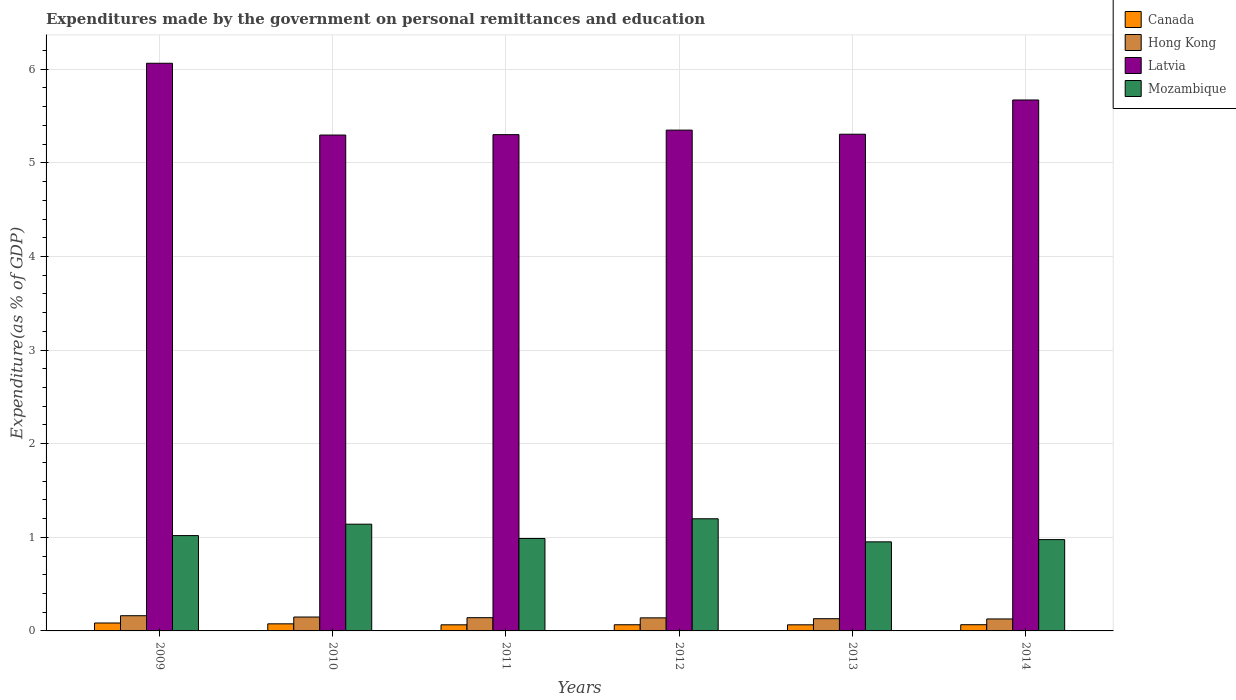Are the number of bars per tick equal to the number of legend labels?
Your answer should be compact. Yes. Are the number of bars on each tick of the X-axis equal?
Your response must be concise. Yes. How many bars are there on the 5th tick from the left?
Give a very brief answer. 4. How many bars are there on the 3rd tick from the right?
Your answer should be compact. 4. What is the label of the 2nd group of bars from the left?
Your answer should be compact. 2010. What is the expenditures made by the government on personal remittances and education in Mozambique in 2011?
Offer a terse response. 0.99. Across all years, what is the maximum expenditures made by the government on personal remittances and education in Latvia?
Your answer should be very brief. 6.06. Across all years, what is the minimum expenditures made by the government on personal remittances and education in Latvia?
Offer a very short reply. 5.3. In which year was the expenditures made by the government on personal remittances and education in Mozambique minimum?
Your answer should be very brief. 2013. What is the total expenditures made by the government on personal remittances and education in Canada in the graph?
Provide a short and direct response. 0.42. What is the difference between the expenditures made by the government on personal remittances and education in Canada in 2013 and that in 2014?
Your response must be concise. -0. What is the difference between the expenditures made by the government on personal remittances and education in Hong Kong in 2011 and the expenditures made by the government on personal remittances and education in Latvia in 2014?
Your answer should be very brief. -5.53. What is the average expenditures made by the government on personal remittances and education in Latvia per year?
Your answer should be very brief. 5.5. In the year 2011, what is the difference between the expenditures made by the government on personal remittances and education in Hong Kong and expenditures made by the government on personal remittances and education in Latvia?
Provide a succinct answer. -5.16. What is the ratio of the expenditures made by the government on personal remittances and education in Hong Kong in 2010 to that in 2012?
Ensure brevity in your answer.  1.06. Is the expenditures made by the government on personal remittances and education in Latvia in 2011 less than that in 2013?
Provide a short and direct response. Yes. Is the difference between the expenditures made by the government on personal remittances and education in Hong Kong in 2009 and 2014 greater than the difference between the expenditures made by the government on personal remittances and education in Latvia in 2009 and 2014?
Keep it short and to the point. No. What is the difference between the highest and the second highest expenditures made by the government on personal remittances and education in Mozambique?
Provide a succinct answer. 0.06. What is the difference between the highest and the lowest expenditures made by the government on personal remittances and education in Mozambique?
Give a very brief answer. 0.25. Is the sum of the expenditures made by the government on personal remittances and education in Hong Kong in 2009 and 2014 greater than the maximum expenditures made by the government on personal remittances and education in Mozambique across all years?
Your answer should be very brief. No. What does the 4th bar from the left in 2009 represents?
Your answer should be very brief. Mozambique. What does the 4th bar from the right in 2010 represents?
Your answer should be very brief. Canada. Is it the case that in every year, the sum of the expenditures made by the government on personal remittances and education in Hong Kong and expenditures made by the government on personal remittances and education in Mozambique is greater than the expenditures made by the government on personal remittances and education in Latvia?
Give a very brief answer. No. How many bars are there?
Ensure brevity in your answer.  24. How many years are there in the graph?
Provide a short and direct response. 6. Does the graph contain grids?
Give a very brief answer. Yes. Where does the legend appear in the graph?
Your answer should be very brief. Top right. What is the title of the graph?
Offer a terse response. Expenditures made by the government on personal remittances and education. What is the label or title of the Y-axis?
Your answer should be very brief. Expenditure(as % of GDP). What is the Expenditure(as % of GDP) in Canada in 2009?
Give a very brief answer. 0.08. What is the Expenditure(as % of GDP) of Hong Kong in 2009?
Offer a terse response. 0.16. What is the Expenditure(as % of GDP) of Latvia in 2009?
Offer a terse response. 6.06. What is the Expenditure(as % of GDP) in Mozambique in 2009?
Offer a terse response. 1.02. What is the Expenditure(as % of GDP) in Canada in 2010?
Your answer should be compact. 0.08. What is the Expenditure(as % of GDP) of Hong Kong in 2010?
Provide a short and direct response. 0.15. What is the Expenditure(as % of GDP) in Latvia in 2010?
Your response must be concise. 5.3. What is the Expenditure(as % of GDP) in Mozambique in 2010?
Offer a terse response. 1.14. What is the Expenditure(as % of GDP) in Canada in 2011?
Ensure brevity in your answer.  0.07. What is the Expenditure(as % of GDP) in Hong Kong in 2011?
Provide a short and direct response. 0.14. What is the Expenditure(as % of GDP) of Latvia in 2011?
Give a very brief answer. 5.3. What is the Expenditure(as % of GDP) in Mozambique in 2011?
Ensure brevity in your answer.  0.99. What is the Expenditure(as % of GDP) of Canada in 2012?
Your response must be concise. 0.07. What is the Expenditure(as % of GDP) in Hong Kong in 2012?
Offer a terse response. 0.14. What is the Expenditure(as % of GDP) of Latvia in 2012?
Give a very brief answer. 5.35. What is the Expenditure(as % of GDP) in Mozambique in 2012?
Provide a succinct answer. 1.2. What is the Expenditure(as % of GDP) in Canada in 2013?
Make the answer very short. 0.07. What is the Expenditure(as % of GDP) in Hong Kong in 2013?
Ensure brevity in your answer.  0.13. What is the Expenditure(as % of GDP) in Latvia in 2013?
Your answer should be very brief. 5.31. What is the Expenditure(as % of GDP) in Mozambique in 2013?
Your answer should be compact. 0.95. What is the Expenditure(as % of GDP) of Canada in 2014?
Ensure brevity in your answer.  0.07. What is the Expenditure(as % of GDP) in Hong Kong in 2014?
Keep it short and to the point. 0.13. What is the Expenditure(as % of GDP) of Latvia in 2014?
Make the answer very short. 5.67. What is the Expenditure(as % of GDP) of Mozambique in 2014?
Offer a very short reply. 0.98. Across all years, what is the maximum Expenditure(as % of GDP) in Canada?
Make the answer very short. 0.08. Across all years, what is the maximum Expenditure(as % of GDP) of Hong Kong?
Offer a very short reply. 0.16. Across all years, what is the maximum Expenditure(as % of GDP) in Latvia?
Keep it short and to the point. 6.06. Across all years, what is the maximum Expenditure(as % of GDP) in Mozambique?
Provide a succinct answer. 1.2. Across all years, what is the minimum Expenditure(as % of GDP) in Canada?
Your answer should be very brief. 0.07. Across all years, what is the minimum Expenditure(as % of GDP) of Hong Kong?
Provide a succinct answer. 0.13. Across all years, what is the minimum Expenditure(as % of GDP) of Latvia?
Your answer should be very brief. 5.3. Across all years, what is the minimum Expenditure(as % of GDP) of Mozambique?
Provide a succinct answer. 0.95. What is the total Expenditure(as % of GDP) of Canada in the graph?
Provide a succinct answer. 0.42. What is the total Expenditure(as % of GDP) of Hong Kong in the graph?
Provide a short and direct response. 0.85. What is the total Expenditure(as % of GDP) of Latvia in the graph?
Provide a short and direct response. 32.99. What is the total Expenditure(as % of GDP) in Mozambique in the graph?
Your answer should be compact. 6.27. What is the difference between the Expenditure(as % of GDP) in Canada in 2009 and that in 2010?
Make the answer very short. 0.01. What is the difference between the Expenditure(as % of GDP) of Hong Kong in 2009 and that in 2010?
Your response must be concise. 0.01. What is the difference between the Expenditure(as % of GDP) in Latvia in 2009 and that in 2010?
Offer a very short reply. 0.77. What is the difference between the Expenditure(as % of GDP) in Mozambique in 2009 and that in 2010?
Make the answer very short. -0.12. What is the difference between the Expenditure(as % of GDP) in Canada in 2009 and that in 2011?
Keep it short and to the point. 0.02. What is the difference between the Expenditure(as % of GDP) in Hong Kong in 2009 and that in 2011?
Your answer should be very brief. 0.02. What is the difference between the Expenditure(as % of GDP) of Latvia in 2009 and that in 2011?
Ensure brevity in your answer.  0.76. What is the difference between the Expenditure(as % of GDP) of Mozambique in 2009 and that in 2011?
Offer a terse response. 0.03. What is the difference between the Expenditure(as % of GDP) of Canada in 2009 and that in 2012?
Your answer should be compact. 0.02. What is the difference between the Expenditure(as % of GDP) in Hong Kong in 2009 and that in 2012?
Provide a succinct answer. 0.02. What is the difference between the Expenditure(as % of GDP) in Latvia in 2009 and that in 2012?
Offer a very short reply. 0.71. What is the difference between the Expenditure(as % of GDP) in Mozambique in 2009 and that in 2012?
Ensure brevity in your answer.  -0.18. What is the difference between the Expenditure(as % of GDP) in Canada in 2009 and that in 2013?
Your answer should be very brief. 0.02. What is the difference between the Expenditure(as % of GDP) of Hong Kong in 2009 and that in 2013?
Give a very brief answer. 0.03. What is the difference between the Expenditure(as % of GDP) of Latvia in 2009 and that in 2013?
Your answer should be very brief. 0.76. What is the difference between the Expenditure(as % of GDP) in Mozambique in 2009 and that in 2013?
Provide a short and direct response. 0.07. What is the difference between the Expenditure(as % of GDP) in Canada in 2009 and that in 2014?
Your answer should be compact. 0.02. What is the difference between the Expenditure(as % of GDP) in Hong Kong in 2009 and that in 2014?
Offer a terse response. 0.03. What is the difference between the Expenditure(as % of GDP) in Latvia in 2009 and that in 2014?
Provide a short and direct response. 0.39. What is the difference between the Expenditure(as % of GDP) of Mozambique in 2009 and that in 2014?
Keep it short and to the point. 0.04. What is the difference between the Expenditure(as % of GDP) in Canada in 2010 and that in 2011?
Provide a short and direct response. 0.01. What is the difference between the Expenditure(as % of GDP) in Hong Kong in 2010 and that in 2011?
Offer a very short reply. 0.01. What is the difference between the Expenditure(as % of GDP) of Latvia in 2010 and that in 2011?
Make the answer very short. -0. What is the difference between the Expenditure(as % of GDP) in Mozambique in 2010 and that in 2011?
Ensure brevity in your answer.  0.15. What is the difference between the Expenditure(as % of GDP) of Canada in 2010 and that in 2012?
Your response must be concise. 0.01. What is the difference between the Expenditure(as % of GDP) of Hong Kong in 2010 and that in 2012?
Make the answer very short. 0.01. What is the difference between the Expenditure(as % of GDP) of Latvia in 2010 and that in 2012?
Offer a very short reply. -0.05. What is the difference between the Expenditure(as % of GDP) of Mozambique in 2010 and that in 2012?
Provide a short and direct response. -0.06. What is the difference between the Expenditure(as % of GDP) of Canada in 2010 and that in 2013?
Give a very brief answer. 0.01. What is the difference between the Expenditure(as % of GDP) of Hong Kong in 2010 and that in 2013?
Offer a terse response. 0.02. What is the difference between the Expenditure(as % of GDP) in Latvia in 2010 and that in 2013?
Provide a short and direct response. -0.01. What is the difference between the Expenditure(as % of GDP) in Mozambique in 2010 and that in 2013?
Ensure brevity in your answer.  0.19. What is the difference between the Expenditure(as % of GDP) of Canada in 2010 and that in 2014?
Give a very brief answer. 0.01. What is the difference between the Expenditure(as % of GDP) in Hong Kong in 2010 and that in 2014?
Give a very brief answer. 0.02. What is the difference between the Expenditure(as % of GDP) of Latvia in 2010 and that in 2014?
Ensure brevity in your answer.  -0.37. What is the difference between the Expenditure(as % of GDP) of Mozambique in 2010 and that in 2014?
Ensure brevity in your answer.  0.16. What is the difference between the Expenditure(as % of GDP) in Canada in 2011 and that in 2012?
Make the answer very short. -0. What is the difference between the Expenditure(as % of GDP) of Hong Kong in 2011 and that in 2012?
Provide a succinct answer. 0. What is the difference between the Expenditure(as % of GDP) of Latvia in 2011 and that in 2012?
Your response must be concise. -0.05. What is the difference between the Expenditure(as % of GDP) of Mozambique in 2011 and that in 2012?
Offer a terse response. -0.21. What is the difference between the Expenditure(as % of GDP) in Canada in 2011 and that in 2013?
Ensure brevity in your answer.  -0. What is the difference between the Expenditure(as % of GDP) of Hong Kong in 2011 and that in 2013?
Keep it short and to the point. 0.01. What is the difference between the Expenditure(as % of GDP) in Latvia in 2011 and that in 2013?
Your answer should be very brief. -0. What is the difference between the Expenditure(as % of GDP) of Mozambique in 2011 and that in 2013?
Make the answer very short. 0.04. What is the difference between the Expenditure(as % of GDP) in Canada in 2011 and that in 2014?
Give a very brief answer. -0. What is the difference between the Expenditure(as % of GDP) in Hong Kong in 2011 and that in 2014?
Give a very brief answer. 0.01. What is the difference between the Expenditure(as % of GDP) of Latvia in 2011 and that in 2014?
Your answer should be compact. -0.37. What is the difference between the Expenditure(as % of GDP) in Mozambique in 2011 and that in 2014?
Your response must be concise. 0.01. What is the difference between the Expenditure(as % of GDP) of Canada in 2012 and that in 2013?
Give a very brief answer. 0. What is the difference between the Expenditure(as % of GDP) of Hong Kong in 2012 and that in 2013?
Provide a short and direct response. 0.01. What is the difference between the Expenditure(as % of GDP) in Latvia in 2012 and that in 2013?
Your answer should be very brief. 0.04. What is the difference between the Expenditure(as % of GDP) in Mozambique in 2012 and that in 2013?
Your answer should be compact. 0.25. What is the difference between the Expenditure(as % of GDP) in Canada in 2012 and that in 2014?
Provide a short and direct response. -0. What is the difference between the Expenditure(as % of GDP) of Hong Kong in 2012 and that in 2014?
Give a very brief answer. 0.01. What is the difference between the Expenditure(as % of GDP) of Latvia in 2012 and that in 2014?
Keep it short and to the point. -0.32. What is the difference between the Expenditure(as % of GDP) of Mozambique in 2012 and that in 2014?
Give a very brief answer. 0.22. What is the difference between the Expenditure(as % of GDP) of Canada in 2013 and that in 2014?
Make the answer very short. -0. What is the difference between the Expenditure(as % of GDP) of Hong Kong in 2013 and that in 2014?
Give a very brief answer. 0. What is the difference between the Expenditure(as % of GDP) of Latvia in 2013 and that in 2014?
Ensure brevity in your answer.  -0.37. What is the difference between the Expenditure(as % of GDP) of Mozambique in 2013 and that in 2014?
Ensure brevity in your answer.  -0.02. What is the difference between the Expenditure(as % of GDP) in Canada in 2009 and the Expenditure(as % of GDP) in Hong Kong in 2010?
Your answer should be compact. -0.06. What is the difference between the Expenditure(as % of GDP) in Canada in 2009 and the Expenditure(as % of GDP) in Latvia in 2010?
Offer a terse response. -5.21. What is the difference between the Expenditure(as % of GDP) in Canada in 2009 and the Expenditure(as % of GDP) in Mozambique in 2010?
Your response must be concise. -1.06. What is the difference between the Expenditure(as % of GDP) in Hong Kong in 2009 and the Expenditure(as % of GDP) in Latvia in 2010?
Offer a terse response. -5.13. What is the difference between the Expenditure(as % of GDP) in Hong Kong in 2009 and the Expenditure(as % of GDP) in Mozambique in 2010?
Keep it short and to the point. -0.98. What is the difference between the Expenditure(as % of GDP) of Latvia in 2009 and the Expenditure(as % of GDP) of Mozambique in 2010?
Keep it short and to the point. 4.92. What is the difference between the Expenditure(as % of GDP) in Canada in 2009 and the Expenditure(as % of GDP) in Hong Kong in 2011?
Provide a succinct answer. -0.06. What is the difference between the Expenditure(as % of GDP) of Canada in 2009 and the Expenditure(as % of GDP) of Latvia in 2011?
Offer a terse response. -5.22. What is the difference between the Expenditure(as % of GDP) of Canada in 2009 and the Expenditure(as % of GDP) of Mozambique in 2011?
Your answer should be very brief. -0.9. What is the difference between the Expenditure(as % of GDP) of Hong Kong in 2009 and the Expenditure(as % of GDP) of Latvia in 2011?
Keep it short and to the point. -5.14. What is the difference between the Expenditure(as % of GDP) in Hong Kong in 2009 and the Expenditure(as % of GDP) in Mozambique in 2011?
Offer a very short reply. -0.82. What is the difference between the Expenditure(as % of GDP) in Latvia in 2009 and the Expenditure(as % of GDP) in Mozambique in 2011?
Your answer should be very brief. 5.08. What is the difference between the Expenditure(as % of GDP) in Canada in 2009 and the Expenditure(as % of GDP) in Hong Kong in 2012?
Provide a short and direct response. -0.06. What is the difference between the Expenditure(as % of GDP) of Canada in 2009 and the Expenditure(as % of GDP) of Latvia in 2012?
Provide a succinct answer. -5.26. What is the difference between the Expenditure(as % of GDP) of Canada in 2009 and the Expenditure(as % of GDP) of Mozambique in 2012?
Make the answer very short. -1.11. What is the difference between the Expenditure(as % of GDP) of Hong Kong in 2009 and the Expenditure(as % of GDP) of Latvia in 2012?
Offer a terse response. -5.19. What is the difference between the Expenditure(as % of GDP) in Hong Kong in 2009 and the Expenditure(as % of GDP) in Mozambique in 2012?
Make the answer very short. -1.04. What is the difference between the Expenditure(as % of GDP) in Latvia in 2009 and the Expenditure(as % of GDP) in Mozambique in 2012?
Offer a terse response. 4.87. What is the difference between the Expenditure(as % of GDP) in Canada in 2009 and the Expenditure(as % of GDP) in Hong Kong in 2013?
Offer a very short reply. -0.05. What is the difference between the Expenditure(as % of GDP) of Canada in 2009 and the Expenditure(as % of GDP) of Latvia in 2013?
Make the answer very short. -5.22. What is the difference between the Expenditure(as % of GDP) in Canada in 2009 and the Expenditure(as % of GDP) in Mozambique in 2013?
Offer a very short reply. -0.87. What is the difference between the Expenditure(as % of GDP) of Hong Kong in 2009 and the Expenditure(as % of GDP) of Latvia in 2013?
Your answer should be compact. -5.14. What is the difference between the Expenditure(as % of GDP) of Hong Kong in 2009 and the Expenditure(as % of GDP) of Mozambique in 2013?
Offer a terse response. -0.79. What is the difference between the Expenditure(as % of GDP) of Latvia in 2009 and the Expenditure(as % of GDP) of Mozambique in 2013?
Ensure brevity in your answer.  5.11. What is the difference between the Expenditure(as % of GDP) of Canada in 2009 and the Expenditure(as % of GDP) of Hong Kong in 2014?
Give a very brief answer. -0.04. What is the difference between the Expenditure(as % of GDP) of Canada in 2009 and the Expenditure(as % of GDP) of Latvia in 2014?
Make the answer very short. -5.59. What is the difference between the Expenditure(as % of GDP) of Canada in 2009 and the Expenditure(as % of GDP) of Mozambique in 2014?
Your answer should be compact. -0.89. What is the difference between the Expenditure(as % of GDP) in Hong Kong in 2009 and the Expenditure(as % of GDP) in Latvia in 2014?
Provide a succinct answer. -5.51. What is the difference between the Expenditure(as % of GDP) in Hong Kong in 2009 and the Expenditure(as % of GDP) in Mozambique in 2014?
Keep it short and to the point. -0.81. What is the difference between the Expenditure(as % of GDP) of Latvia in 2009 and the Expenditure(as % of GDP) of Mozambique in 2014?
Ensure brevity in your answer.  5.09. What is the difference between the Expenditure(as % of GDP) of Canada in 2010 and the Expenditure(as % of GDP) of Hong Kong in 2011?
Give a very brief answer. -0.07. What is the difference between the Expenditure(as % of GDP) in Canada in 2010 and the Expenditure(as % of GDP) in Latvia in 2011?
Ensure brevity in your answer.  -5.23. What is the difference between the Expenditure(as % of GDP) of Canada in 2010 and the Expenditure(as % of GDP) of Mozambique in 2011?
Keep it short and to the point. -0.91. What is the difference between the Expenditure(as % of GDP) of Hong Kong in 2010 and the Expenditure(as % of GDP) of Latvia in 2011?
Offer a very short reply. -5.15. What is the difference between the Expenditure(as % of GDP) in Hong Kong in 2010 and the Expenditure(as % of GDP) in Mozambique in 2011?
Offer a terse response. -0.84. What is the difference between the Expenditure(as % of GDP) of Latvia in 2010 and the Expenditure(as % of GDP) of Mozambique in 2011?
Make the answer very short. 4.31. What is the difference between the Expenditure(as % of GDP) in Canada in 2010 and the Expenditure(as % of GDP) in Hong Kong in 2012?
Your answer should be very brief. -0.06. What is the difference between the Expenditure(as % of GDP) in Canada in 2010 and the Expenditure(as % of GDP) in Latvia in 2012?
Your response must be concise. -5.27. What is the difference between the Expenditure(as % of GDP) in Canada in 2010 and the Expenditure(as % of GDP) in Mozambique in 2012?
Provide a succinct answer. -1.12. What is the difference between the Expenditure(as % of GDP) in Hong Kong in 2010 and the Expenditure(as % of GDP) in Latvia in 2012?
Provide a succinct answer. -5.2. What is the difference between the Expenditure(as % of GDP) of Hong Kong in 2010 and the Expenditure(as % of GDP) of Mozambique in 2012?
Ensure brevity in your answer.  -1.05. What is the difference between the Expenditure(as % of GDP) in Latvia in 2010 and the Expenditure(as % of GDP) in Mozambique in 2012?
Make the answer very short. 4.1. What is the difference between the Expenditure(as % of GDP) in Canada in 2010 and the Expenditure(as % of GDP) in Hong Kong in 2013?
Your answer should be very brief. -0.05. What is the difference between the Expenditure(as % of GDP) of Canada in 2010 and the Expenditure(as % of GDP) of Latvia in 2013?
Ensure brevity in your answer.  -5.23. What is the difference between the Expenditure(as % of GDP) in Canada in 2010 and the Expenditure(as % of GDP) in Mozambique in 2013?
Provide a succinct answer. -0.88. What is the difference between the Expenditure(as % of GDP) of Hong Kong in 2010 and the Expenditure(as % of GDP) of Latvia in 2013?
Provide a succinct answer. -5.16. What is the difference between the Expenditure(as % of GDP) in Hong Kong in 2010 and the Expenditure(as % of GDP) in Mozambique in 2013?
Your response must be concise. -0.8. What is the difference between the Expenditure(as % of GDP) in Latvia in 2010 and the Expenditure(as % of GDP) in Mozambique in 2013?
Provide a succinct answer. 4.35. What is the difference between the Expenditure(as % of GDP) of Canada in 2010 and the Expenditure(as % of GDP) of Hong Kong in 2014?
Make the answer very short. -0.05. What is the difference between the Expenditure(as % of GDP) of Canada in 2010 and the Expenditure(as % of GDP) of Latvia in 2014?
Your response must be concise. -5.6. What is the difference between the Expenditure(as % of GDP) in Canada in 2010 and the Expenditure(as % of GDP) in Mozambique in 2014?
Provide a succinct answer. -0.9. What is the difference between the Expenditure(as % of GDP) of Hong Kong in 2010 and the Expenditure(as % of GDP) of Latvia in 2014?
Your answer should be compact. -5.52. What is the difference between the Expenditure(as % of GDP) of Hong Kong in 2010 and the Expenditure(as % of GDP) of Mozambique in 2014?
Your response must be concise. -0.83. What is the difference between the Expenditure(as % of GDP) in Latvia in 2010 and the Expenditure(as % of GDP) in Mozambique in 2014?
Offer a terse response. 4.32. What is the difference between the Expenditure(as % of GDP) of Canada in 2011 and the Expenditure(as % of GDP) of Hong Kong in 2012?
Offer a very short reply. -0.07. What is the difference between the Expenditure(as % of GDP) of Canada in 2011 and the Expenditure(as % of GDP) of Latvia in 2012?
Ensure brevity in your answer.  -5.28. What is the difference between the Expenditure(as % of GDP) of Canada in 2011 and the Expenditure(as % of GDP) of Mozambique in 2012?
Keep it short and to the point. -1.13. What is the difference between the Expenditure(as % of GDP) in Hong Kong in 2011 and the Expenditure(as % of GDP) in Latvia in 2012?
Ensure brevity in your answer.  -5.21. What is the difference between the Expenditure(as % of GDP) in Hong Kong in 2011 and the Expenditure(as % of GDP) in Mozambique in 2012?
Keep it short and to the point. -1.06. What is the difference between the Expenditure(as % of GDP) of Latvia in 2011 and the Expenditure(as % of GDP) of Mozambique in 2012?
Keep it short and to the point. 4.1. What is the difference between the Expenditure(as % of GDP) of Canada in 2011 and the Expenditure(as % of GDP) of Hong Kong in 2013?
Your answer should be very brief. -0.07. What is the difference between the Expenditure(as % of GDP) in Canada in 2011 and the Expenditure(as % of GDP) in Latvia in 2013?
Your response must be concise. -5.24. What is the difference between the Expenditure(as % of GDP) in Canada in 2011 and the Expenditure(as % of GDP) in Mozambique in 2013?
Make the answer very short. -0.89. What is the difference between the Expenditure(as % of GDP) of Hong Kong in 2011 and the Expenditure(as % of GDP) of Latvia in 2013?
Offer a terse response. -5.16. What is the difference between the Expenditure(as % of GDP) of Hong Kong in 2011 and the Expenditure(as % of GDP) of Mozambique in 2013?
Your answer should be compact. -0.81. What is the difference between the Expenditure(as % of GDP) of Latvia in 2011 and the Expenditure(as % of GDP) of Mozambique in 2013?
Ensure brevity in your answer.  4.35. What is the difference between the Expenditure(as % of GDP) in Canada in 2011 and the Expenditure(as % of GDP) in Hong Kong in 2014?
Give a very brief answer. -0.06. What is the difference between the Expenditure(as % of GDP) of Canada in 2011 and the Expenditure(as % of GDP) of Latvia in 2014?
Your answer should be very brief. -5.61. What is the difference between the Expenditure(as % of GDP) in Canada in 2011 and the Expenditure(as % of GDP) in Mozambique in 2014?
Keep it short and to the point. -0.91. What is the difference between the Expenditure(as % of GDP) of Hong Kong in 2011 and the Expenditure(as % of GDP) of Latvia in 2014?
Keep it short and to the point. -5.53. What is the difference between the Expenditure(as % of GDP) in Hong Kong in 2011 and the Expenditure(as % of GDP) in Mozambique in 2014?
Offer a terse response. -0.83. What is the difference between the Expenditure(as % of GDP) of Latvia in 2011 and the Expenditure(as % of GDP) of Mozambique in 2014?
Your answer should be compact. 4.33. What is the difference between the Expenditure(as % of GDP) in Canada in 2012 and the Expenditure(as % of GDP) in Hong Kong in 2013?
Your response must be concise. -0.06. What is the difference between the Expenditure(as % of GDP) in Canada in 2012 and the Expenditure(as % of GDP) in Latvia in 2013?
Offer a very short reply. -5.24. What is the difference between the Expenditure(as % of GDP) in Canada in 2012 and the Expenditure(as % of GDP) in Mozambique in 2013?
Provide a succinct answer. -0.89. What is the difference between the Expenditure(as % of GDP) in Hong Kong in 2012 and the Expenditure(as % of GDP) in Latvia in 2013?
Provide a succinct answer. -5.17. What is the difference between the Expenditure(as % of GDP) in Hong Kong in 2012 and the Expenditure(as % of GDP) in Mozambique in 2013?
Keep it short and to the point. -0.81. What is the difference between the Expenditure(as % of GDP) of Latvia in 2012 and the Expenditure(as % of GDP) of Mozambique in 2013?
Ensure brevity in your answer.  4.4. What is the difference between the Expenditure(as % of GDP) in Canada in 2012 and the Expenditure(as % of GDP) in Hong Kong in 2014?
Your response must be concise. -0.06. What is the difference between the Expenditure(as % of GDP) of Canada in 2012 and the Expenditure(as % of GDP) of Latvia in 2014?
Give a very brief answer. -5.61. What is the difference between the Expenditure(as % of GDP) in Canada in 2012 and the Expenditure(as % of GDP) in Mozambique in 2014?
Offer a terse response. -0.91. What is the difference between the Expenditure(as % of GDP) of Hong Kong in 2012 and the Expenditure(as % of GDP) of Latvia in 2014?
Your answer should be very brief. -5.53. What is the difference between the Expenditure(as % of GDP) of Hong Kong in 2012 and the Expenditure(as % of GDP) of Mozambique in 2014?
Your response must be concise. -0.84. What is the difference between the Expenditure(as % of GDP) in Latvia in 2012 and the Expenditure(as % of GDP) in Mozambique in 2014?
Your answer should be very brief. 4.37. What is the difference between the Expenditure(as % of GDP) in Canada in 2013 and the Expenditure(as % of GDP) in Hong Kong in 2014?
Ensure brevity in your answer.  -0.06. What is the difference between the Expenditure(as % of GDP) of Canada in 2013 and the Expenditure(as % of GDP) of Latvia in 2014?
Your answer should be very brief. -5.61. What is the difference between the Expenditure(as % of GDP) in Canada in 2013 and the Expenditure(as % of GDP) in Mozambique in 2014?
Keep it short and to the point. -0.91. What is the difference between the Expenditure(as % of GDP) in Hong Kong in 2013 and the Expenditure(as % of GDP) in Latvia in 2014?
Your response must be concise. -5.54. What is the difference between the Expenditure(as % of GDP) of Hong Kong in 2013 and the Expenditure(as % of GDP) of Mozambique in 2014?
Your answer should be compact. -0.84. What is the difference between the Expenditure(as % of GDP) of Latvia in 2013 and the Expenditure(as % of GDP) of Mozambique in 2014?
Your answer should be compact. 4.33. What is the average Expenditure(as % of GDP) in Canada per year?
Your response must be concise. 0.07. What is the average Expenditure(as % of GDP) of Hong Kong per year?
Provide a succinct answer. 0.14. What is the average Expenditure(as % of GDP) in Latvia per year?
Ensure brevity in your answer.  5.5. What is the average Expenditure(as % of GDP) of Mozambique per year?
Your answer should be very brief. 1.05. In the year 2009, what is the difference between the Expenditure(as % of GDP) in Canada and Expenditure(as % of GDP) in Hong Kong?
Keep it short and to the point. -0.08. In the year 2009, what is the difference between the Expenditure(as % of GDP) of Canada and Expenditure(as % of GDP) of Latvia?
Your answer should be compact. -5.98. In the year 2009, what is the difference between the Expenditure(as % of GDP) in Canada and Expenditure(as % of GDP) in Mozambique?
Provide a short and direct response. -0.93. In the year 2009, what is the difference between the Expenditure(as % of GDP) in Hong Kong and Expenditure(as % of GDP) in Latvia?
Offer a terse response. -5.9. In the year 2009, what is the difference between the Expenditure(as % of GDP) of Hong Kong and Expenditure(as % of GDP) of Mozambique?
Make the answer very short. -0.86. In the year 2009, what is the difference between the Expenditure(as % of GDP) of Latvia and Expenditure(as % of GDP) of Mozambique?
Provide a short and direct response. 5.05. In the year 2010, what is the difference between the Expenditure(as % of GDP) of Canada and Expenditure(as % of GDP) of Hong Kong?
Give a very brief answer. -0.07. In the year 2010, what is the difference between the Expenditure(as % of GDP) in Canada and Expenditure(as % of GDP) in Latvia?
Provide a succinct answer. -5.22. In the year 2010, what is the difference between the Expenditure(as % of GDP) in Canada and Expenditure(as % of GDP) in Mozambique?
Ensure brevity in your answer.  -1.06. In the year 2010, what is the difference between the Expenditure(as % of GDP) in Hong Kong and Expenditure(as % of GDP) in Latvia?
Your response must be concise. -5.15. In the year 2010, what is the difference between the Expenditure(as % of GDP) of Hong Kong and Expenditure(as % of GDP) of Mozambique?
Keep it short and to the point. -0.99. In the year 2010, what is the difference between the Expenditure(as % of GDP) in Latvia and Expenditure(as % of GDP) in Mozambique?
Your answer should be very brief. 4.16. In the year 2011, what is the difference between the Expenditure(as % of GDP) in Canada and Expenditure(as % of GDP) in Hong Kong?
Offer a terse response. -0.08. In the year 2011, what is the difference between the Expenditure(as % of GDP) of Canada and Expenditure(as % of GDP) of Latvia?
Offer a very short reply. -5.24. In the year 2011, what is the difference between the Expenditure(as % of GDP) of Canada and Expenditure(as % of GDP) of Mozambique?
Give a very brief answer. -0.92. In the year 2011, what is the difference between the Expenditure(as % of GDP) in Hong Kong and Expenditure(as % of GDP) in Latvia?
Offer a terse response. -5.16. In the year 2011, what is the difference between the Expenditure(as % of GDP) in Hong Kong and Expenditure(as % of GDP) in Mozambique?
Your answer should be very brief. -0.85. In the year 2011, what is the difference between the Expenditure(as % of GDP) of Latvia and Expenditure(as % of GDP) of Mozambique?
Provide a short and direct response. 4.31. In the year 2012, what is the difference between the Expenditure(as % of GDP) of Canada and Expenditure(as % of GDP) of Hong Kong?
Offer a very short reply. -0.07. In the year 2012, what is the difference between the Expenditure(as % of GDP) of Canada and Expenditure(as % of GDP) of Latvia?
Offer a terse response. -5.28. In the year 2012, what is the difference between the Expenditure(as % of GDP) of Canada and Expenditure(as % of GDP) of Mozambique?
Your answer should be very brief. -1.13. In the year 2012, what is the difference between the Expenditure(as % of GDP) in Hong Kong and Expenditure(as % of GDP) in Latvia?
Keep it short and to the point. -5.21. In the year 2012, what is the difference between the Expenditure(as % of GDP) of Hong Kong and Expenditure(as % of GDP) of Mozambique?
Offer a terse response. -1.06. In the year 2012, what is the difference between the Expenditure(as % of GDP) in Latvia and Expenditure(as % of GDP) in Mozambique?
Your answer should be very brief. 4.15. In the year 2013, what is the difference between the Expenditure(as % of GDP) in Canada and Expenditure(as % of GDP) in Hong Kong?
Your response must be concise. -0.07. In the year 2013, what is the difference between the Expenditure(as % of GDP) in Canada and Expenditure(as % of GDP) in Latvia?
Make the answer very short. -5.24. In the year 2013, what is the difference between the Expenditure(as % of GDP) of Canada and Expenditure(as % of GDP) of Mozambique?
Your answer should be compact. -0.89. In the year 2013, what is the difference between the Expenditure(as % of GDP) in Hong Kong and Expenditure(as % of GDP) in Latvia?
Provide a short and direct response. -5.17. In the year 2013, what is the difference between the Expenditure(as % of GDP) in Hong Kong and Expenditure(as % of GDP) in Mozambique?
Offer a very short reply. -0.82. In the year 2013, what is the difference between the Expenditure(as % of GDP) of Latvia and Expenditure(as % of GDP) of Mozambique?
Provide a short and direct response. 4.35. In the year 2014, what is the difference between the Expenditure(as % of GDP) of Canada and Expenditure(as % of GDP) of Hong Kong?
Your response must be concise. -0.06. In the year 2014, what is the difference between the Expenditure(as % of GDP) in Canada and Expenditure(as % of GDP) in Latvia?
Provide a short and direct response. -5.61. In the year 2014, what is the difference between the Expenditure(as % of GDP) in Canada and Expenditure(as % of GDP) in Mozambique?
Offer a terse response. -0.91. In the year 2014, what is the difference between the Expenditure(as % of GDP) of Hong Kong and Expenditure(as % of GDP) of Latvia?
Offer a terse response. -5.54. In the year 2014, what is the difference between the Expenditure(as % of GDP) in Hong Kong and Expenditure(as % of GDP) in Mozambique?
Keep it short and to the point. -0.85. In the year 2014, what is the difference between the Expenditure(as % of GDP) of Latvia and Expenditure(as % of GDP) of Mozambique?
Your answer should be compact. 4.7. What is the ratio of the Expenditure(as % of GDP) of Canada in 2009 to that in 2010?
Your answer should be very brief. 1.12. What is the ratio of the Expenditure(as % of GDP) of Hong Kong in 2009 to that in 2010?
Provide a short and direct response. 1.09. What is the ratio of the Expenditure(as % of GDP) of Latvia in 2009 to that in 2010?
Give a very brief answer. 1.14. What is the ratio of the Expenditure(as % of GDP) in Mozambique in 2009 to that in 2010?
Provide a succinct answer. 0.89. What is the ratio of the Expenditure(as % of GDP) of Canada in 2009 to that in 2011?
Your response must be concise. 1.3. What is the ratio of the Expenditure(as % of GDP) of Hong Kong in 2009 to that in 2011?
Offer a very short reply. 1.15. What is the ratio of the Expenditure(as % of GDP) of Latvia in 2009 to that in 2011?
Provide a succinct answer. 1.14. What is the ratio of the Expenditure(as % of GDP) in Mozambique in 2009 to that in 2011?
Offer a very short reply. 1.03. What is the ratio of the Expenditure(as % of GDP) in Canada in 2009 to that in 2012?
Provide a succinct answer. 1.29. What is the ratio of the Expenditure(as % of GDP) of Hong Kong in 2009 to that in 2012?
Your answer should be very brief. 1.16. What is the ratio of the Expenditure(as % of GDP) of Latvia in 2009 to that in 2012?
Offer a terse response. 1.13. What is the ratio of the Expenditure(as % of GDP) of Mozambique in 2009 to that in 2012?
Ensure brevity in your answer.  0.85. What is the ratio of the Expenditure(as % of GDP) in Canada in 2009 to that in 2013?
Your answer should be very brief. 1.3. What is the ratio of the Expenditure(as % of GDP) of Hong Kong in 2009 to that in 2013?
Your answer should be very brief. 1.24. What is the ratio of the Expenditure(as % of GDP) in Mozambique in 2009 to that in 2013?
Keep it short and to the point. 1.07. What is the ratio of the Expenditure(as % of GDP) of Canada in 2009 to that in 2014?
Offer a terse response. 1.28. What is the ratio of the Expenditure(as % of GDP) in Hong Kong in 2009 to that in 2014?
Offer a terse response. 1.27. What is the ratio of the Expenditure(as % of GDP) in Latvia in 2009 to that in 2014?
Your answer should be very brief. 1.07. What is the ratio of the Expenditure(as % of GDP) in Mozambique in 2009 to that in 2014?
Your response must be concise. 1.04. What is the ratio of the Expenditure(as % of GDP) in Canada in 2010 to that in 2011?
Make the answer very short. 1.16. What is the ratio of the Expenditure(as % of GDP) of Hong Kong in 2010 to that in 2011?
Keep it short and to the point. 1.05. What is the ratio of the Expenditure(as % of GDP) of Mozambique in 2010 to that in 2011?
Your answer should be very brief. 1.15. What is the ratio of the Expenditure(as % of GDP) in Canada in 2010 to that in 2012?
Keep it short and to the point. 1.15. What is the ratio of the Expenditure(as % of GDP) in Hong Kong in 2010 to that in 2012?
Keep it short and to the point. 1.06. What is the ratio of the Expenditure(as % of GDP) in Latvia in 2010 to that in 2012?
Your answer should be compact. 0.99. What is the ratio of the Expenditure(as % of GDP) of Mozambique in 2010 to that in 2012?
Your response must be concise. 0.95. What is the ratio of the Expenditure(as % of GDP) of Canada in 2010 to that in 2013?
Provide a succinct answer. 1.16. What is the ratio of the Expenditure(as % of GDP) of Hong Kong in 2010 to that in 2013?
Offer a terse response. 1.14. What is the ratio of the Expenditure(as % of GDP) in Latvia in 2010 to that in 2013?
Offer a terse response. 1. What is the ratio of the Expenditure(as % of GDP) of Mozambique in 2010 to that in 2013?
Keep it short and to the point. 1.2. What is the ratio of the Expenditure(as % of GDP) in Canada in 2010 to that in 2014?
Give a very brief answer. 1.14. What is the ratio of the Expenditure(as % of GDP) in Hong Kong in 2010 to that in 2014?
Offer a very short reply. 1.16. What is the ratio of the Expenditure(as % of GDP) of Latvia in 2010 to that in 2014?
Provide a short and direct response. 0.93. What is the ratio of the Expenditure(as % of GDP) in Mozambique in 2010 to that in 2014?
Your answer should be very brief. 1.17. What is the ratio of the Expenditure(as % of GDP) of Canada in 2011 to that in 2012?
Your answer should be very brief. 0.99. What is the ratio of the Expenditure(as % of GDP) of Hong Kong in 2011 to that in 2012?
Keep it short and to the point. 1.01. What is the ratio of the Expenditure(as % of GDP) of Latvia in 2011 to that in 2012?
Give a very brief answer. 0.99. What is the ratio of the Expenditure(as % of GDP) of Mozambique in 2011 to that in 2012?
Your answer should be very brief. 0.82. What is the ratio of the Expenditure(as % of GDP) in Hong Kong in 2011 to that in 2013?
Offer a very short reply. 1.08. What is the ratio of the Expenditure(as % of GDP) in Latvia in 2011 to that in 2013?
Provide a short and direct response. 1. What is the ratio of the Expenditure(as % of GDP) in Mozambique in 2011 to that in 2013?
Your answer should be very brief. 1.04. What is the ratio of the Expenditure(as % of GDP) in Canada in 2011 to that in 2014?
Provide a succinct answer. 0.98. What is the ratio of the Expenditure(as % of GDP) of Hong Kong in 2011 to that in 2014?
Make the answer very short. 1.11. What is the ratio of the Expenditure(as % of GDP) of Latvia in 2011 to that in 2014?
Ensure brevity in your answer.  0.93. What is the ratio of the Expenditure(as % of GDP) in Mozambique in 2011 to that in 2014?
Your response must be concise. 1.01. What is the ratio of the Expenditure(as % of GDP) of Canada in 2012 to that in 2013?
Offer a very short reply. 1.01. What is the ratio of the Expenditure(as % of GDP) of Hong Kong in 2012 to that in 2013?
Keep it short and to the point. 1.07. What is the ratio of the Expenditure(as % of GDP) of Latvia in 2012 to that in 2013?
Your answer should be compact. 1.01. What is the ratio of the Expenditure(as % of GDP) of Mozambique in 2012 to that in 2013?
Your response must be concise. 1.26. What is the ratio of the Expenditure(as % of GDP) of Canada in 2012 to that in 2014?
Your answer should be compact. 0.99. What is the ratio of the Expenditure(as % of GDP) of Hong Kong in 2012 to that in 2014?
Make the answer very short. 1.09. What is the ratio of the Expenditure(as % of GDP) in Latvia in 2012 to that in 2014?
Give a very brief answer. 0.94. What is the ratio of the Expenditure(as % of GDP) of Mozambique in 2012 to that in 2014?
Your answer should be very brief. 1.23. What is the ratio of the Expenditure(as % of GDP) of Canada in 2013 to that in 2014?
Offer a very short reply. 0.98. What is the ratio of the Expenditure(as % of GDP) in Hong Kong in 2013 to that in 2014?
Offer a terse response. 1.02. What is the ratio of the Expenditure(as % of GDP) in Latvia in 2013 to that in 2014?
Offer a very short reply. 0.94. What is the ratio of the Expenditure(as % of GDP) of Mozambique in 2013 to that in 2014?
Provide a short and direct response. 0.98. What is the difference between the highest and the second highest Expenditure(as % of GDP) of Canada?
Keep it short and to the point. 0.01. What is the difference between the highest and the second highest Expenditure(as % of GDP) in Hong Kong?
Keep it short and to the point. 0.01. What is the difference between the highest and the second highest Expenditure(as % of GDP) in Latvia?
Keep it short and to the point. 0.39. What is the difference between the highest and the second highest Expenditure(as % of GDP) of Mozambique?
Make the answer very short. 0.06. What is the difference between the highest and the lowest Expenditure(as % of GDP) of Canada?
Provide a short and direct response. 0.02. What is the difference between the highest and the lowest Expenditure(as % of GDP) in Hong Kong?
Provide a short and direct response. 0.03. What is the difference between the highest and the lowest Expenditure(as % of GDP) in Latvia?
Offer a very short reply. 0.77. What is the difference between the highest and the lowest Expenditure(as % of GDP) in Mozambique?
Offer a very short reply. 0.25. 